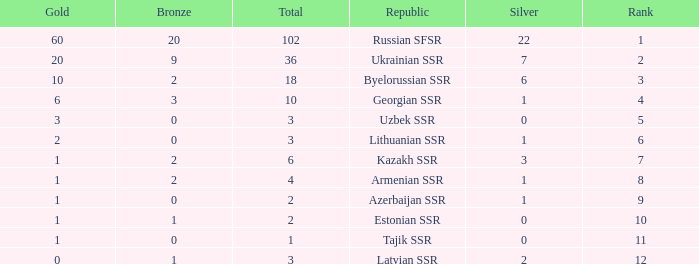What is the average total for teams with more than 1 gold, ranked over 3 and more than 3 bronze? None. 